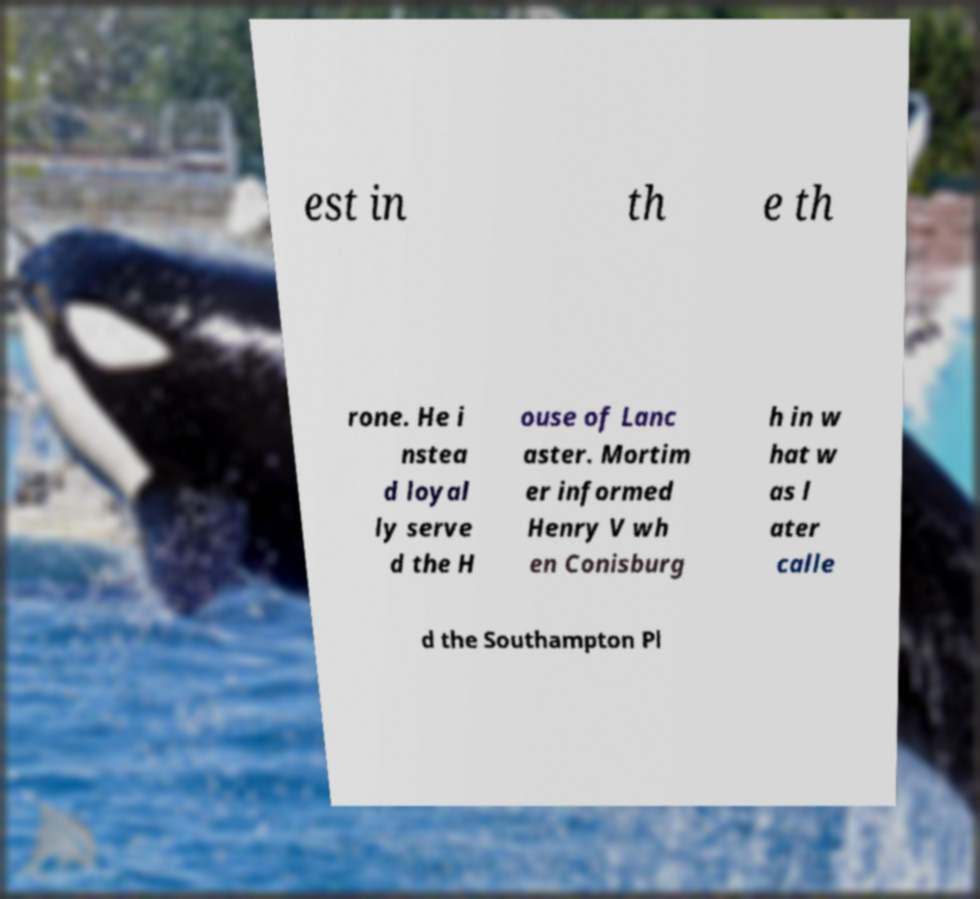What messages or text are displayed in this image? I need them in a readable, typed format. est in th e th rone. He i nstea d loyal ly serve d the H ouse of Lanc aster. Mortim er informed Henry V wh en Conisburg h in w hat w as l ater calle d the Southampton Pl 